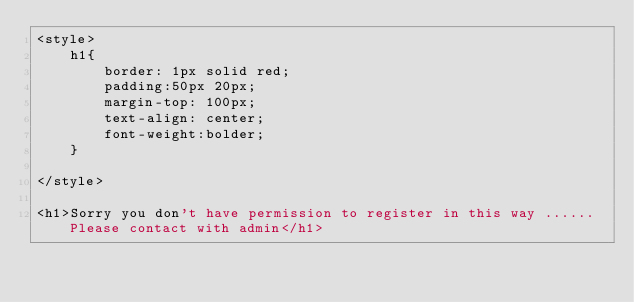<code> <loc_0><loc_0><loc_500><loc_500><_PHP_><style>
    h1{
        border: 1px solid red;
        padding:50px 20px;
        margin-top: 100px;
        text-align: center;
        font-weight:bolder;
    }
    
</style>

<h1>Sorry you don't have permission to register in this way ...... Please contact with admin</h1></code> 